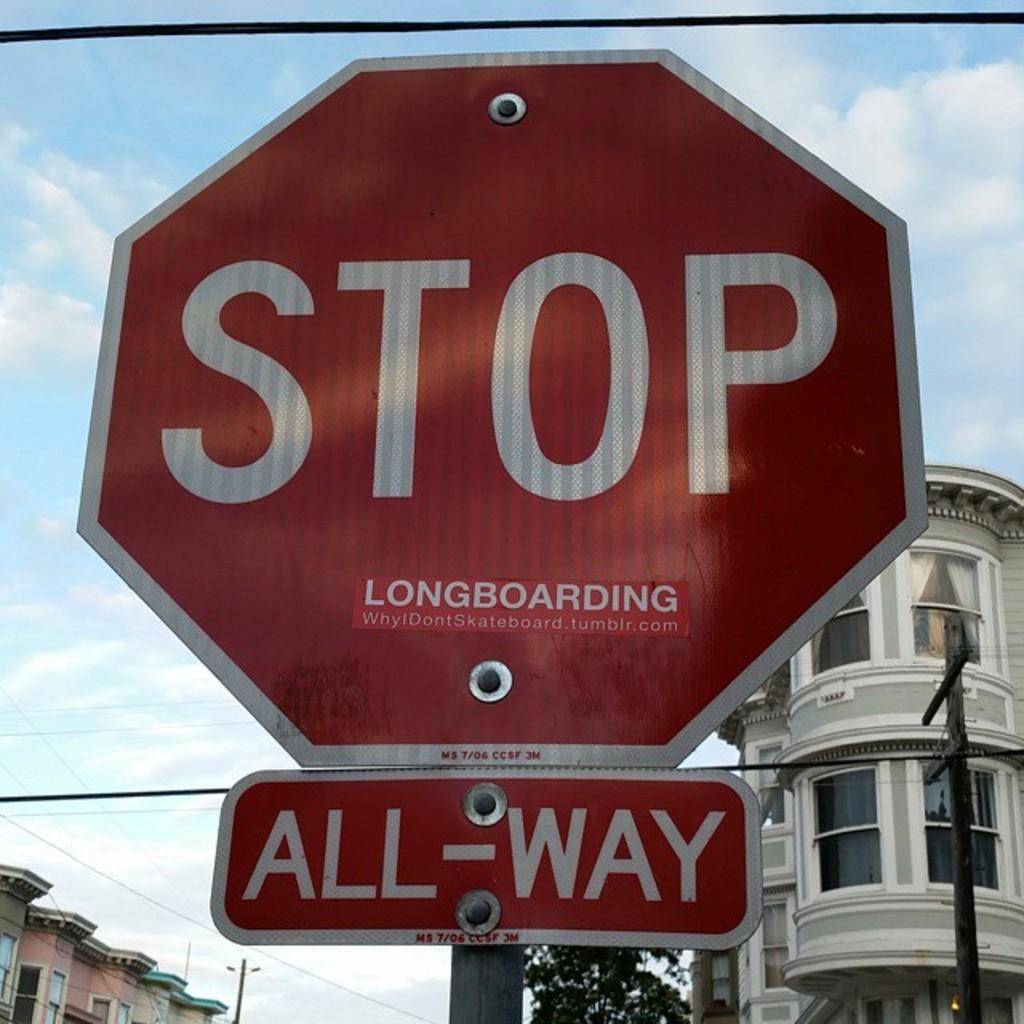What object is the main subject in the image? There is a spine board in the image. What can be seen in the background of the image? There are buildings visible in the background of the image. What type of natural vegetation is visible in the image? There are trees visible in the image. What type of bone is being used to blow up the brick wall in the image? There is no bone, blowing, or brick wall present in the image. 